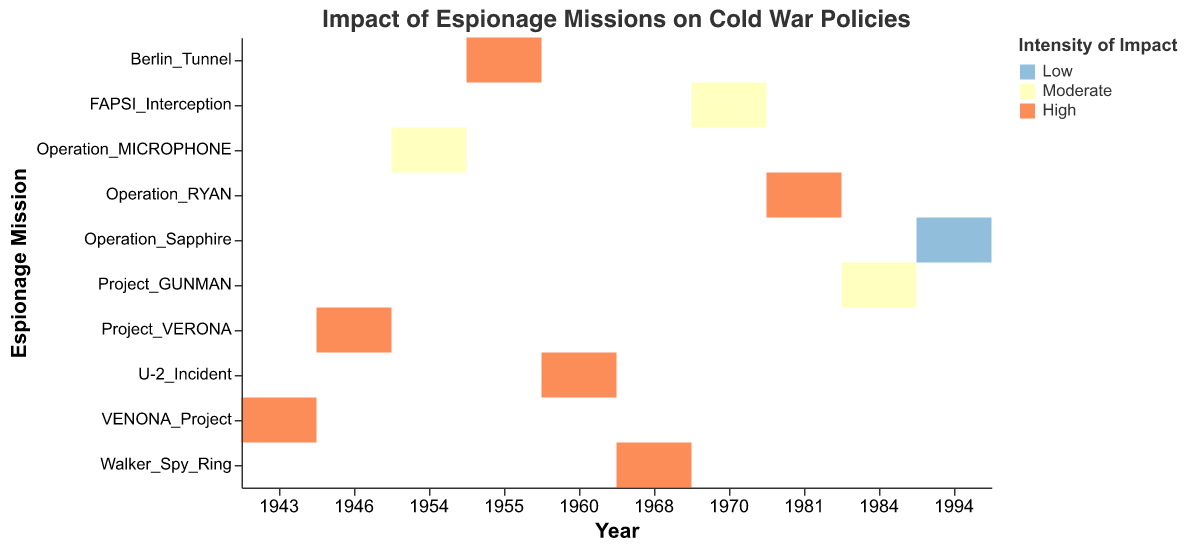What is the title of the heatmap? The title is generally found at the top of the heatmap and provides a summary of what the heatmap illustrates. In this instance, the title describes the overall topic and context, specifically the impact of espionage on Cold War policies.
Answer: Impact of Espionage Missions on Cold War Policies Which espionage missions have both "USSR" and "USA" impacted? Review the y-axis for espionage missions and check if both the "USSR" and "USA" columns display "Yes" for the respective missions.
Answer: U-2_Incident, VENONA_Project In what year did the Operation Sapphire take place and what was its intensity of impact? Locate Operation Sapphire on the y-axis, then read the corresponding year and the color coding for intensity on the heatmap. Operation Sapphire is shown to take place in 1994, with a low intensity of impact as indicated by a specific color.
Answer: 1994, Low Compare the impact intensity of Operation RYAN and FAPSI Interception. Which has a higher intensity? Check the color coding for both Operation RYAN and FAPSI Interception on the heatmap to determine their respective impact intensities. Operation RYAN is marked as high, while FAPSI Interception is moderate.
Answer: Operation RYAN How many espionage missions have a high intensity of impact and which countries affected them? Identify the number of espionage missions that are color-coded as high intensity in the heatmap. Then, check both USSR and USA columns to see which country is impacted.
Answer: 6 missions; USSR: 5 missions, USA: 3 missions Which espionage mission affected "Military Operations" policy area and what kind of information was obtained? Find the row related to the policy areas affected by "Military Operations" and check the corresponding espionage mission as well as the type of information collected in that mission.
Answer: U-2_Incident, Aerial_Imagery How does the intensity of impact vary over different types of information obtained? Scan the heatmap for different information types and observe the variations in color coding, indicating different intensities of impact. Summarize the findings based on color distribution.
Answer: A mix of high, moderate, and low intensities across various information types What is the median intensity of impact among all the espionage missions? List all the intensities of impact marked on the heatmap, arrange them in ascending order, and find the middle value to determine the median.
Answer: High 